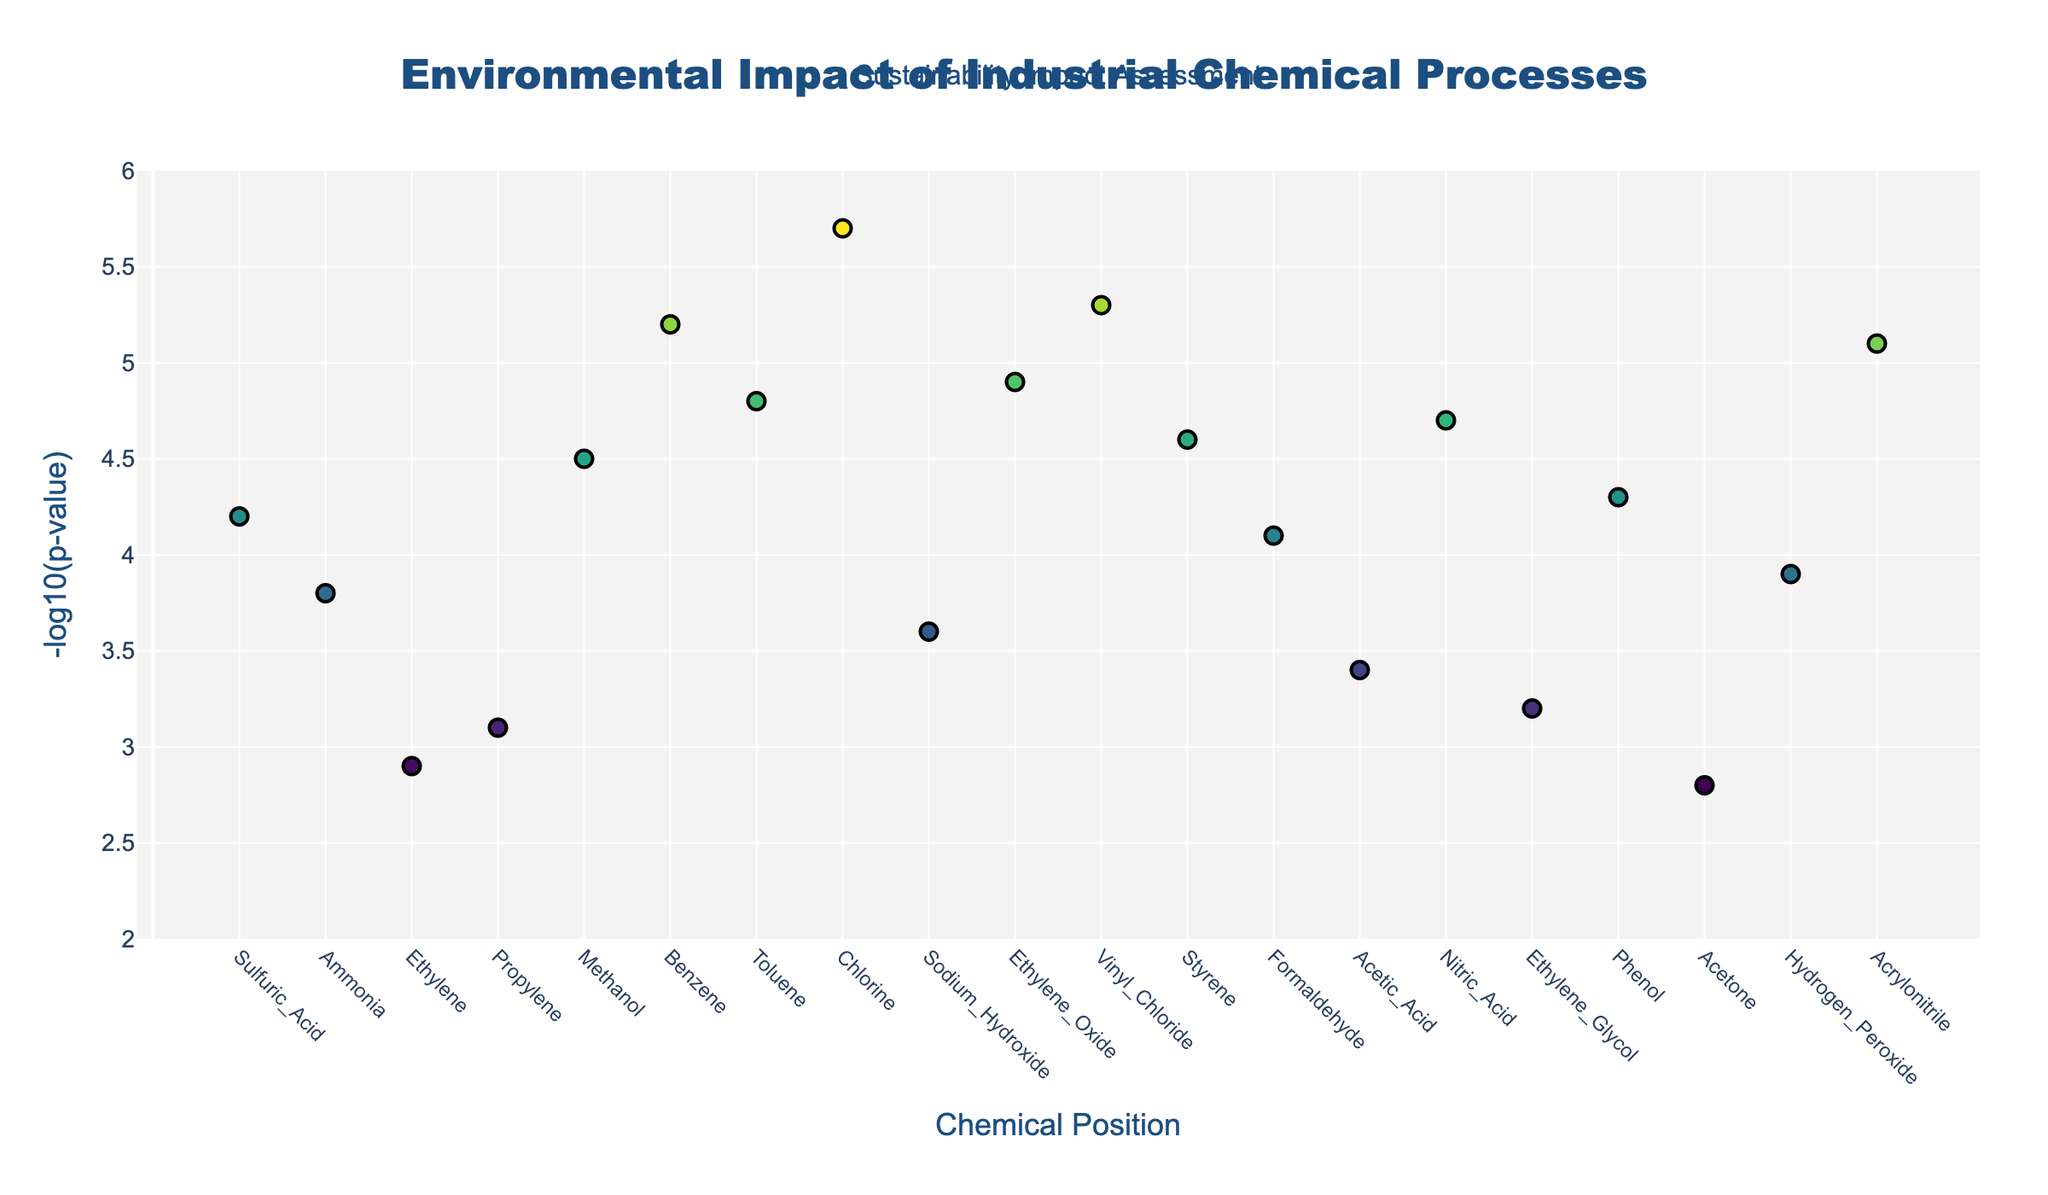What's the title of the plot? The plot’s title is located at the top of the figure. It reads "Environmental Impact of Industrial Chemical Processes."
Answer: Environmental Impact of Industrial Chemical Processes What does the x-axis represent? The x-axis represents "Chemical Position" and shows the positions of various industrial chemicals, indicated by tick labels that are the names of the chemicals.
Answer: Chemical Position How many chemicals have a -log10(p-value) higher than 5? The y-axis represents the -log10(p-value), and by inspecting the plot, the chemicals with -log10(p-values) higher than 5 are Benzene, Chlorine, Vinyl Chloride, and Acrylonitrile. Counting these, there are 4 chemicals.
Answer: 4 Which chemical has the highest -log10(p-value) and what is it? The highest -log10(p-value) can be identified by looking for the data point with the greatest y-value. The highest value is associated with Chlorine, which has a -log10(p-value) of 5.7.
Answer: Chlorine, 5.7 What is the approximate -log10(p-value) for Methanol? Locate Methanol on the x-axis and then check its corresponding y-value, which is around 4.5.
Answer: 4.5 How does the -log10(p-value) for Ethylene Glycol compare to that of Ammonia? Locate both Ethylene Glycol and Ammonia on the x-axis. The -log10(p-value) for Ethylene Glycol is 3.2, and for Ammonia, it is 3.8. Ammonia has a higher -log10(p-value) compared to Ethylene Glycol.
Answer: Ammonia has a higher -log10(p-value) What is the median -log10(p-value) of all the chemicals? List all -log10(p-values) and order them: 2.8, 2.9, 3.1, 3.2, 3.4, 3.6, 3.8, 3.9, 4.1, 4.2, 4.3, 4.5, 4.6, 4.7, 4.8, 4.9, 5.1, 5.2, 5.3, 5.7. The median is the middle value in this ordered list, which is 4.3 (10th value).
Answer: 4.3 Which chemicals have a -log10(p-value) close to 4.0? By examining the y-values around 4.0, the chemicals with -log10(p-values) near this value are Sulfuric Acid (4.2), Formaldehyde (4.1), and Hydrogen Peroxide (3.9).
Answer: Sulfuric Acid, Formaldehyde, Hydrogen Peroxide Which three chemicals have the lowest -log10(p-values)? Locate the three lowest y-values in the plot, which correspond to Acetone (2.8), Ethylene (2.9), and Propylene (3.1).
Answer: Acetone, Ethylene, Propylene 